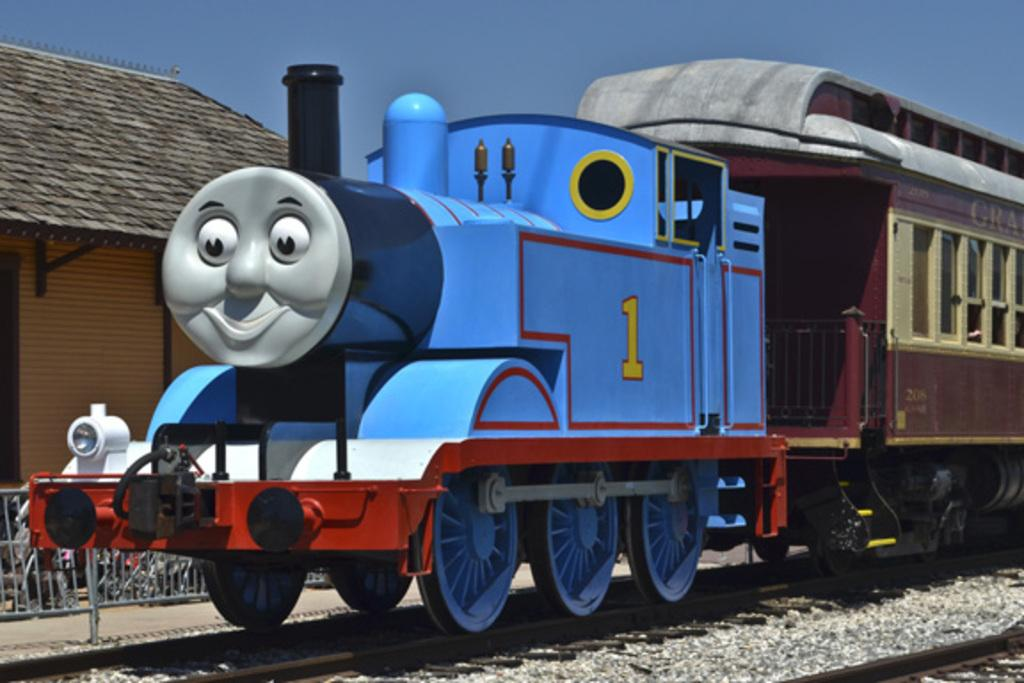<image>
Give a short and clear explanation of the subsequent image. Blue train with a face and the number 1 on it. 